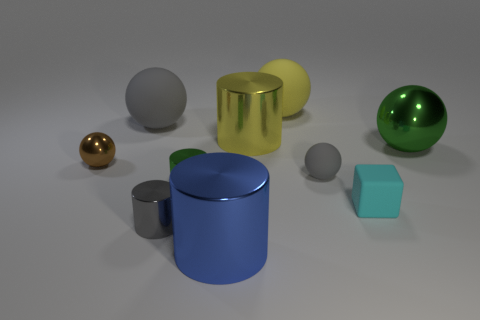Can you describe the colors of the objects depicted in the image? Certainly! The image features objects of various colors: one is gold, another is silver, a third object is green with a metallic sheen, there's also a blue cylinder, a smaller golden sphere, a grayish sphere, and a small matte turquoise block. 